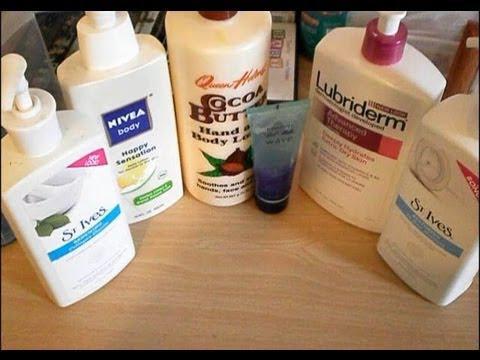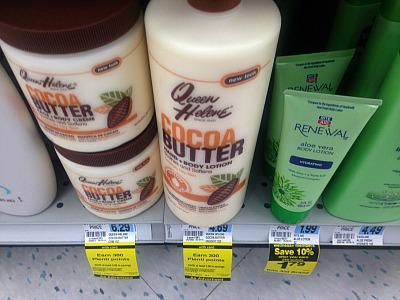The first image is the image on the left, the second image is the image on the right. Considering the images on both sides, is "The items in the image on the left are on surfaces of the same color." valid? Answer yes or no. Yes. The first image is the image on the left, the second image is the image on the right. For the images displayed, is the sentence "Left image contains no more than 2 lotion products." factually correct? Answer yes or no. No. 